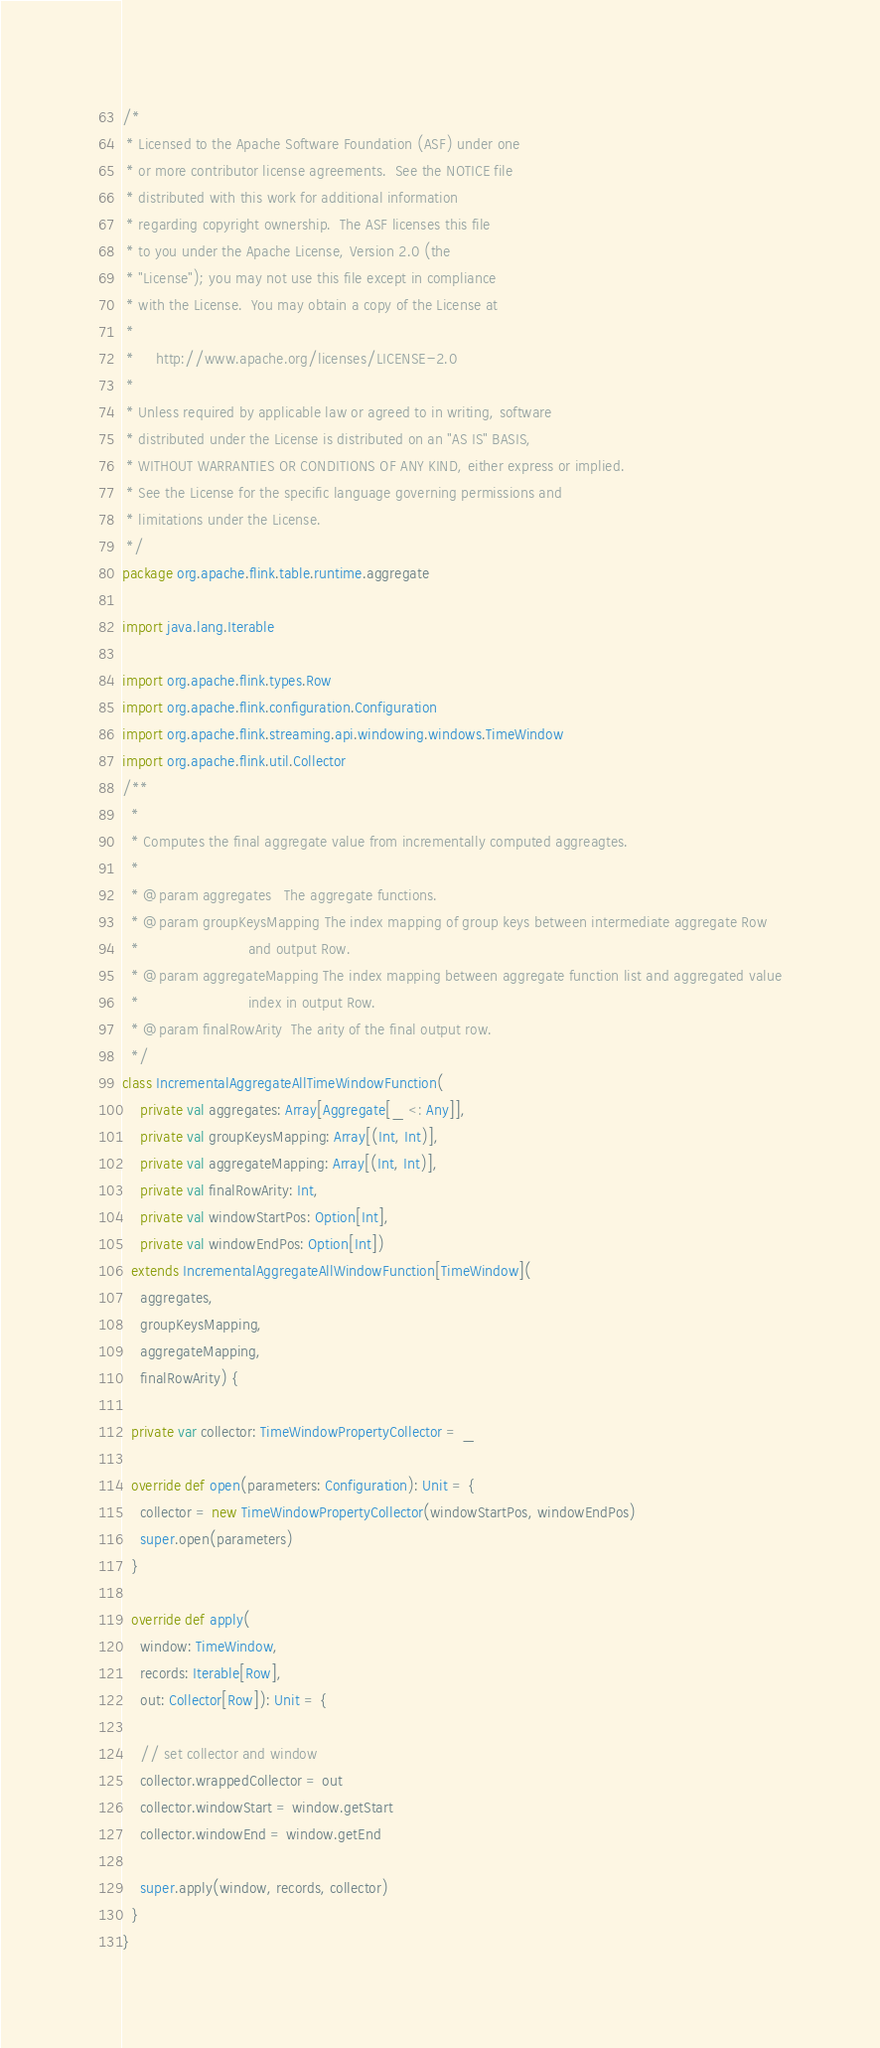Convert code to text. <code><loc_0><loc_0><loc_500><loc_500><_Scala_>/*
 * Licensed to the Apache Software Foundation (ASF) under one
 * or more contributor license agreements.  See the NOTICE file
 * distributed with this work for additional information
 * regarding copyright ownership.  The ASF licenses this file
 * to you under the Apache License, Version 2.0 (the
 * "License"); you may not use this file except in compliance
 * with the License.  You may obtain a copy of the License at
 *
 *     http://www.apache.org/licenses/LICENSE-2.0
 *
 * Unless required by applicable law or agreed to in writing, software
 * distributed under the License is distributed on an "AS IS" BASIS,
 * WITHOUT WARRANTIES OR CONDITIONS OF ANY KIND, either express or implied.
 * See the License for the specific language governing permissions and
 * limitations under the License.
 */
package org.apache.flink.table.runtime.aggregate

import java.lang.Iterable

import org.apache.flink.types.Row
import org.apache.flink.configuration.Configuration
import org.apache.flink.streaming.api.windowing.windows.TimeWindow
import org.apache.flink.util.Collector
/**
  *
  * Computes the final aggregate value from incrementally computed aggreagtes.
  *
  * @param aggregates   The aggregate functions.
  * @param groupKeysMapping The index mapping of group keys between intermediate aggregate Row
  *                         and output Row.
  * @param aggregateMapping The index mapping between aggregate function list and aggregated value
  *                         index in output Row.
  * @param finalRowArity  The arity of the final output row.
  */
class IncrementalAggregateAllTimeWindowFunction(
    private val aggregates: Array[Aggregate[_ <: Any]],
    private val groupKeysMapping: Array[(Int, Int)],
    private val aggregateMapping: Array[(Int, Int)],
    private val finalRowArity: Int,
    private val windowStartPos: Option[Int],
    private val windowEndPos: Option[Int])
  extends IncrementalAggregateAllWindowFunction[TimeWindow](
    aggregates,
    groupKeysMapping,
    aggregateMapping,
    finalRowArity) {

  private var collector: TimeWindowPropertyCollector = _

  override def open(parameters: Configuration): Unit = {
    collector = new TimeWindowPropertyCollector(windowStartPos, windowEndPos)
    super.open(parameters)
  }

  override def apply(
    window: TimeWindow,
    records: Iterable[Row],
    out: Collector[Row]): Unit = {

    // set collector and window
    collector.wrappedCollector = out
    collector.windowStart = window.getStart
    collector.windowEnd = window.getEnd

    super.apply(window, records, collector)
  }
}
</code> 